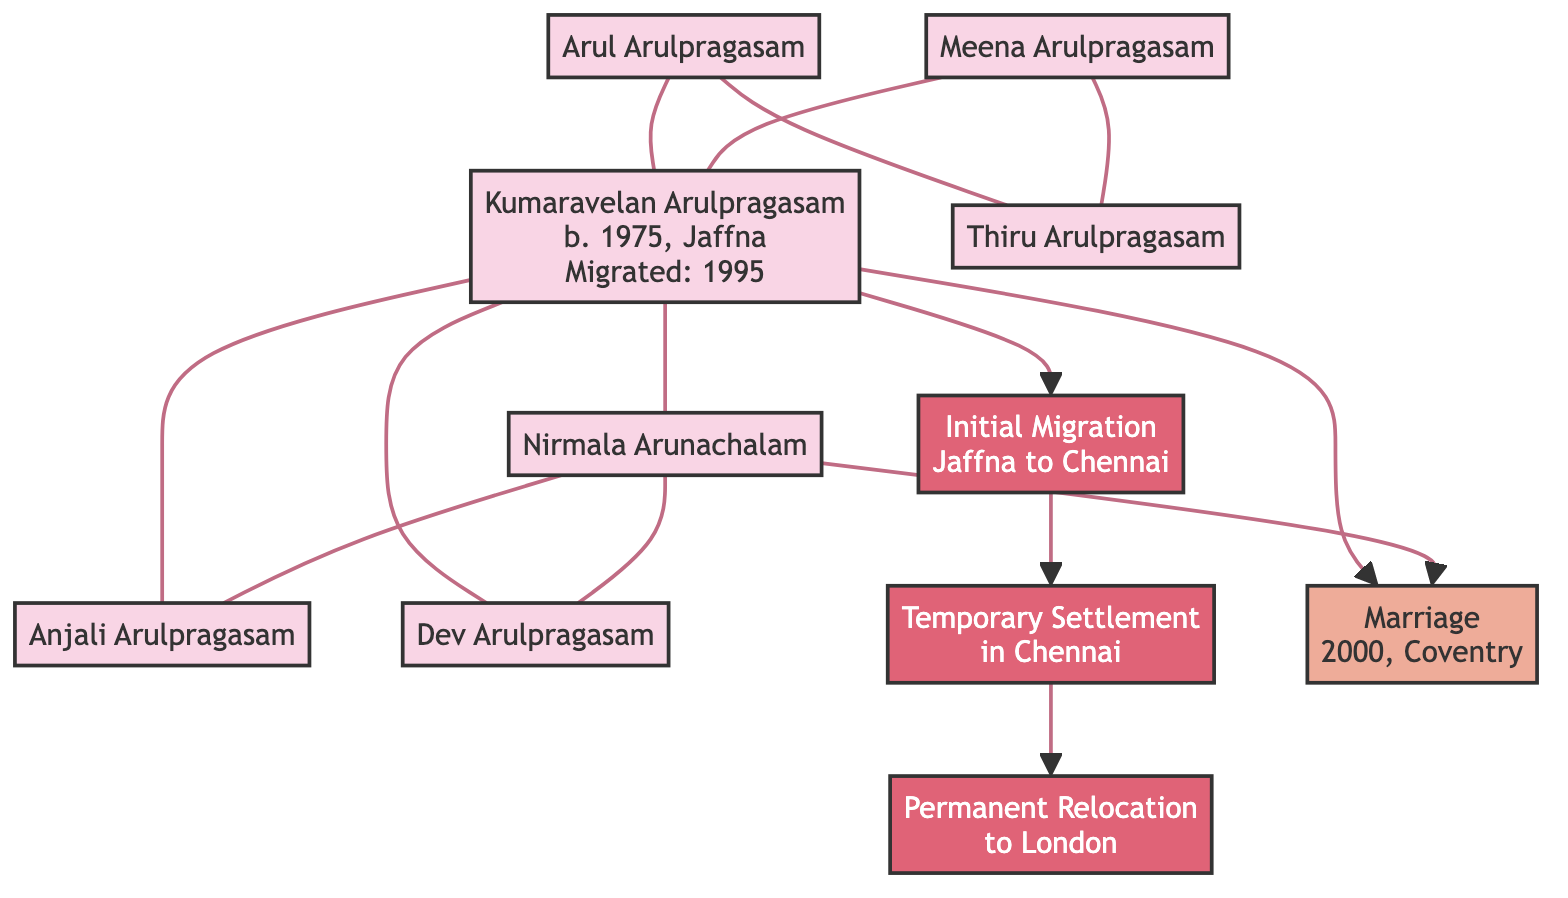What is the name of Kumaravelan Arulpragasam's spouse? The diagram shows a direct connection between Kumaravelan Arulpragasam and Nirmala Arunachalam, indicating she is his spouse.
Answer: Nirmala Arunachalam How many children does Kumaravelan Arulpragasam have? The diagram lists two individual nodes connected to Kumaravelan Arulpragasam for his children, Anjali Arulpragasam and Dev Arulpragasam.
Answer: 2 In what year did Kumaravelan Arulpragasam migrate to the United Kingdom? The diagram explicitly states that Kumaravelan Arulpragasam migrated in 1995, as noted beside his name.
Answer: 1995 What was the primary reason for Kumaravelan Arulpragasam's migration? The diagram indicates the migration reason as "Civil War," which is associated with his migration details.
Answer: Civil War What is the first migration stage listed in the diagram? The diagram outlines stages of migration, and the first one is described as "Initial Migration from Jaffna to Chennai."
Answer: Initial Migration from Jaffna to Chennai Which city is listed as Kumaravelan Arulpragasam's current city? The diagram states that Kumaravelan Arulpragasam currently resides in London, as noted under his individual attributes.
Answer: London How is Thiru Arulpragasam related to Kumaravelan Arulpragasam? The diagram shows a connection indicating that Thiru Arulpragasam is a sibling of Kumaravelan Arulpragasam, as both share the same parents.
Answer: Sibling When did Kumaravelan Arulpragasam get married? The diagram provides the event of marriage as happening in 2000, derived from the marriage event node connected to Kumaravelan Arulpragasam.
Answer: 2000 What event does "E1" in the diagram represent? The diagram labels "E1" specifically as a "Marriage" event and connects it to the individuals involved, Kumaravelan Arulpragasam and Nirmala Arunachalam.
Answer: Marriage 